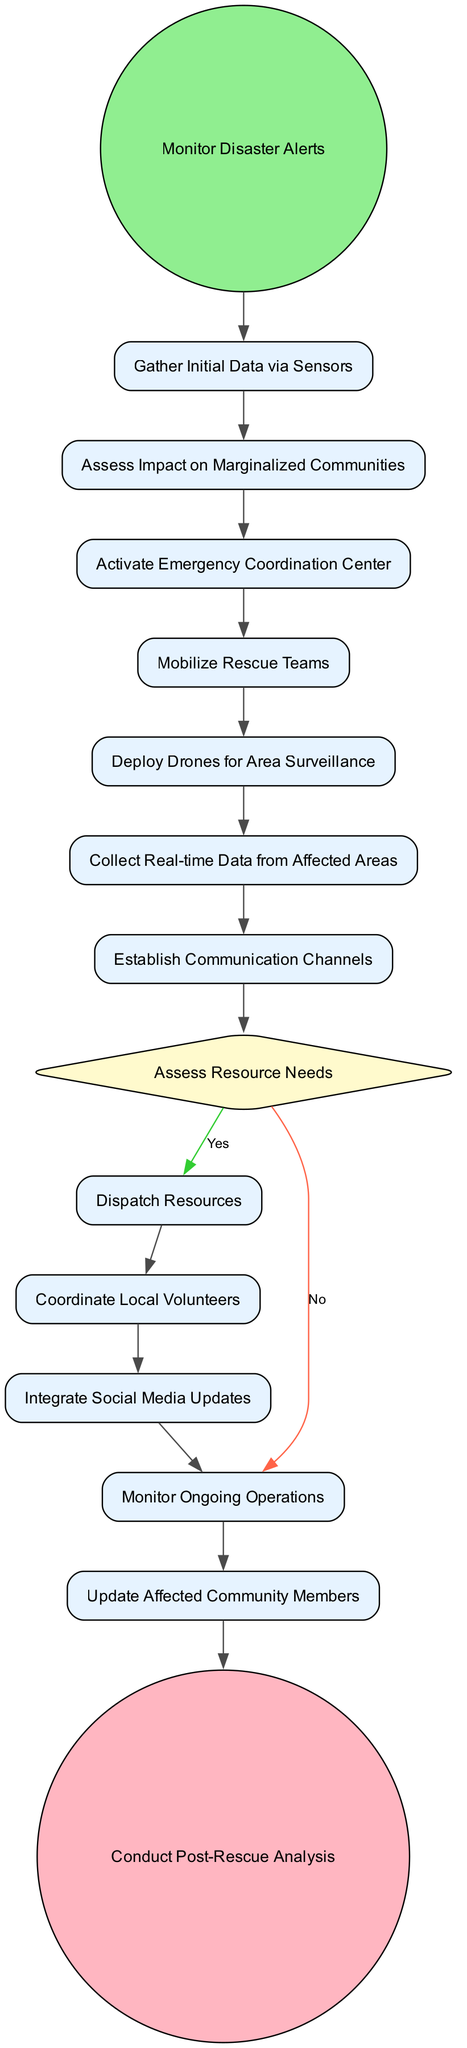What is the first action in the diagram? The diagram starts with the "Monitor Disaster Alerts" action, which initiates the flow of the rescue operations process.
Answer: Monitor Disaster Alerts How many actions are there in total? There are 10 actions listed in the diagram, which detail the steps in the coordination of rescue operations.
Answer: 10 What decision is made after establishing communication channels? The decision made after establishing communication channels is to "Assess Resource Needs", determining whether resources need to be dispatched or not.
Answer: Assess Resource Needs Which activity follows "Dispatch Resources"? The activity that follows "Dispatch Resources" is "Coordinate Local Volunteers", indicating the next step in the resource allocation process.
Answer: Coordinate Local Volunteers What action is taken if the resource needs are not dispatched? If the resource needs are not dispatched, the next action is to "Monitor Ongoing Operations", which allows for continuous evaluation of the rescue efforts.
Answer: Monitor Ongoing Operations Which action comes before "Conduct Post-Rescue Analysis"? The action immediately before "Conduct Post-Rescue Analysis" is "Update Affected Community Members", reflecting the importance of informing the community following rescue operations.
Answer: Update Affected Community Members What node type is used for "Assess Impact on Marginalized Communities"? The node type for "Assess Impact on Marginalized Communities" is classified as an "Action" because it describes an operation that needs to be performed in the process.
Answer: Action Is there an action that takes place after "Deploy Drones for Area Surveillance"? Yes, the action that occurs after "Deploy Drones for Area Surveillance" is "Collect Real-time Data from Affected Areas", indicating a continuation of the monitoring process.
Answer: Collect Real-time Data from Affected Areas What happens if the resource needs are assessed as insufficient? If the resource needs are assessed as insufficient, the flow leads to the action "Dispatch Resources", which indicates the requirement for additional supplies or support.
Answer: Dispatch Resources 